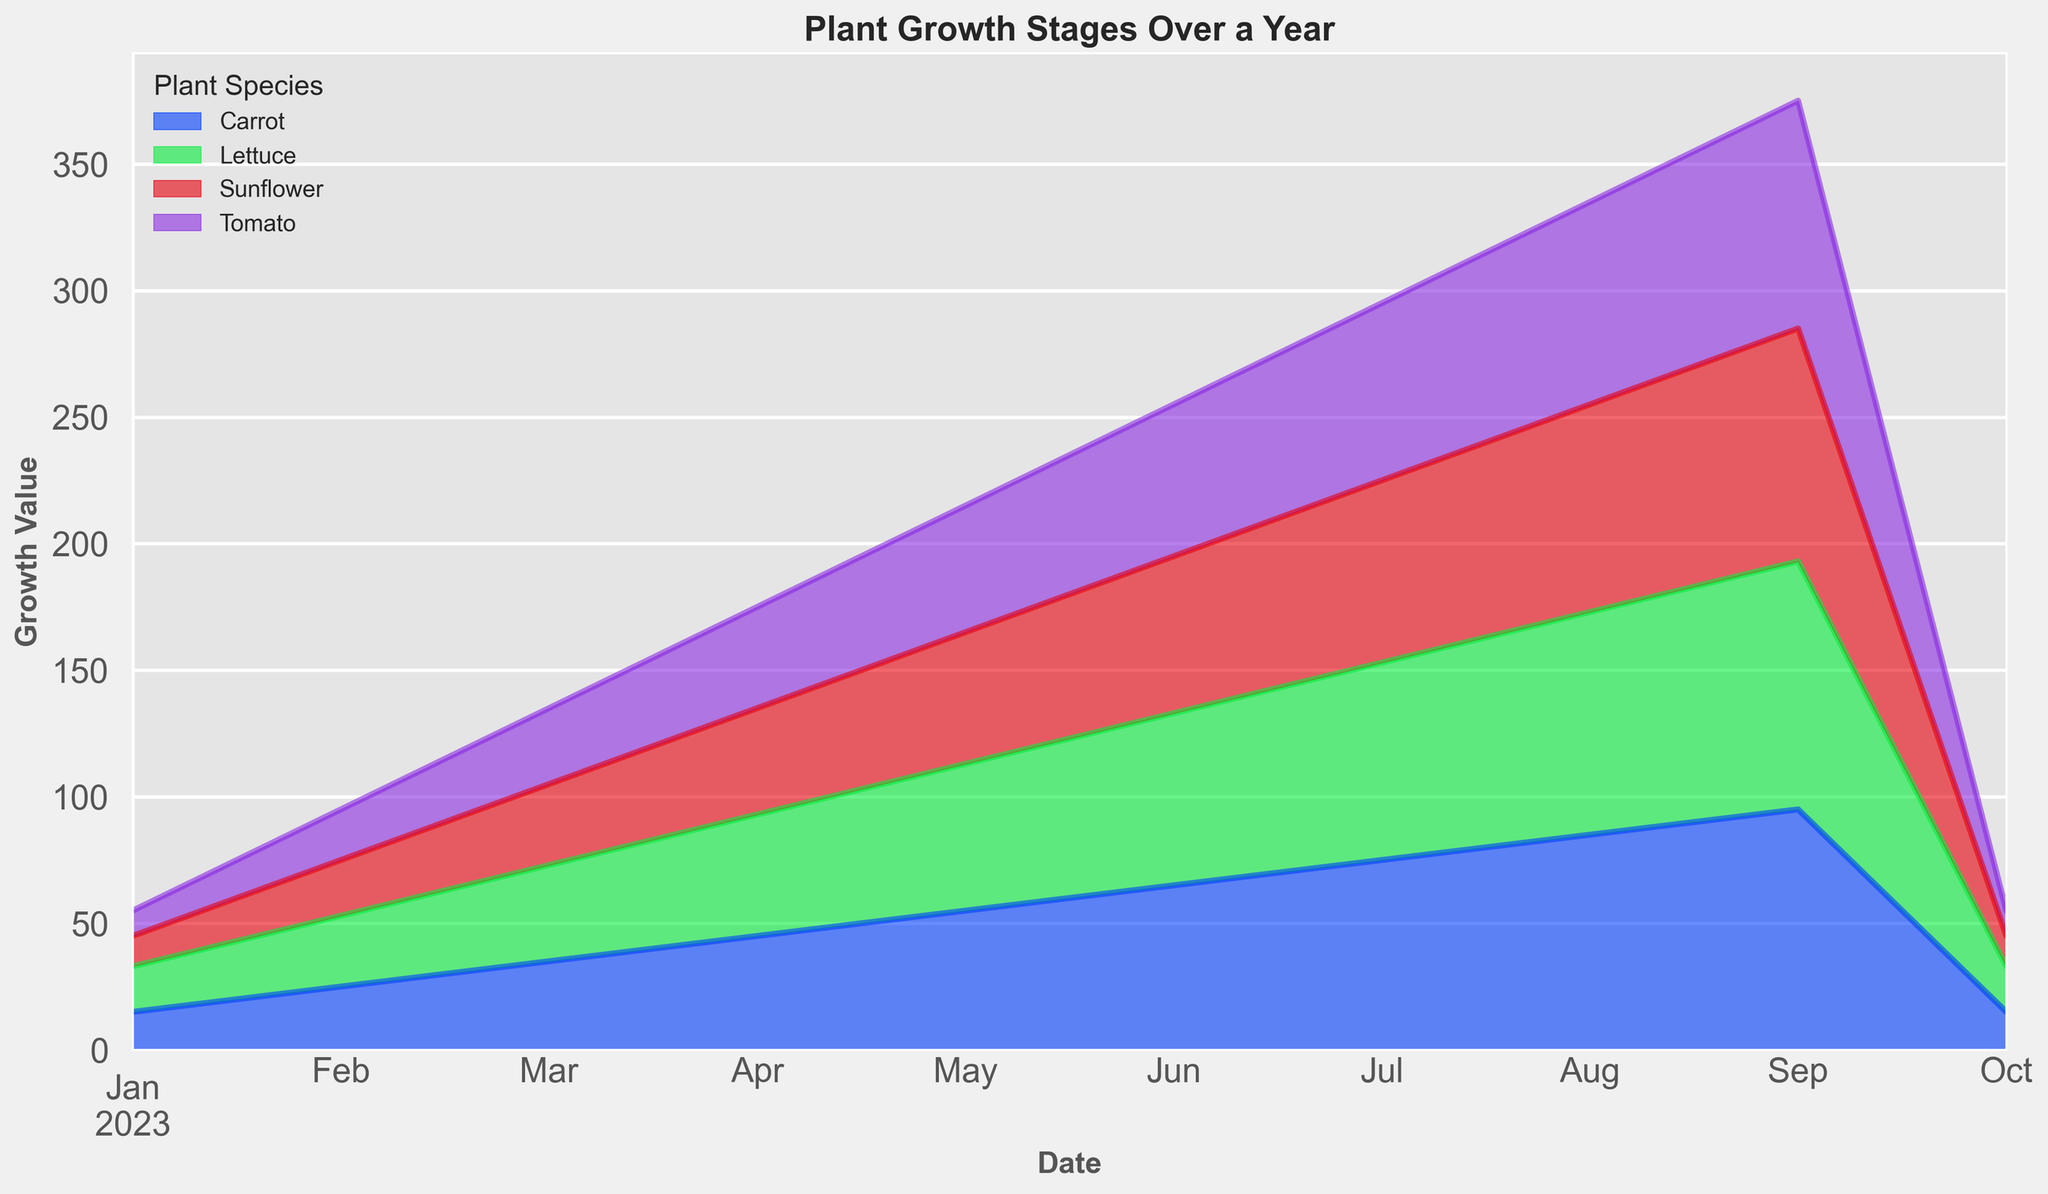Which plant species has the highest growth value during the Fruiting stage? Look at the Fruiting stage values on the graph for each plant species. The values are: Tomato (70 in July), Carrot (75 in July), Sunflower (72 in July), and Lettuce (78 in July). Thus, Lettuce has the highest growth value during the Fruiting stage.
Answer: Lettuce What is the difference in growth value between Tomato and Carrot during the Harvest stage? Check the growth values for Tomato and Carrot during the Harvest stage. Tomato has a value of 90 and Carrot has a value of 95. The difference is 95 - 90 = 5.
Answer: 5 What is the average growth value of a Sunflower across all stages? Sum up the growth values for Sunflower across all stages: 12 (Germination) + 22 (Seedling) + 32 (Vegetative) + 42 (Flowering) + 52 (Fruiting in May) + 62 (Fruiting in June) + 72 (Fruiting in July) + 82 (Mature) + 92 (Harvest) + 12 (Post-Harvest). The total is 480. There are 10 stages, so the average is 480 / 10 = 48.
Answer: 48 Which plant species shows the fastest growing rate from Germination to Seedling stage? Calculate the change from Germination to Seedling for each species: Tomato increases by 10 (20-10), Carrot by 10 (25-15), Sunflower by 10 (22-12), and Lettuce by 10 (28-18). All plant species have the same growth rate increase from Germination to Seedling.
Answer: All plant species Which stage shows the highest overall growth value across all plant species? Aggregate the growth values for all plant species at each stage and identify the maximum. For example, at Fruiting: Tomato (70) + Carrot (75) + Sunflower (72) + Lettuce (78) = 295. Calculate and compare similarly for other stages.
Answer: Harvest stage 